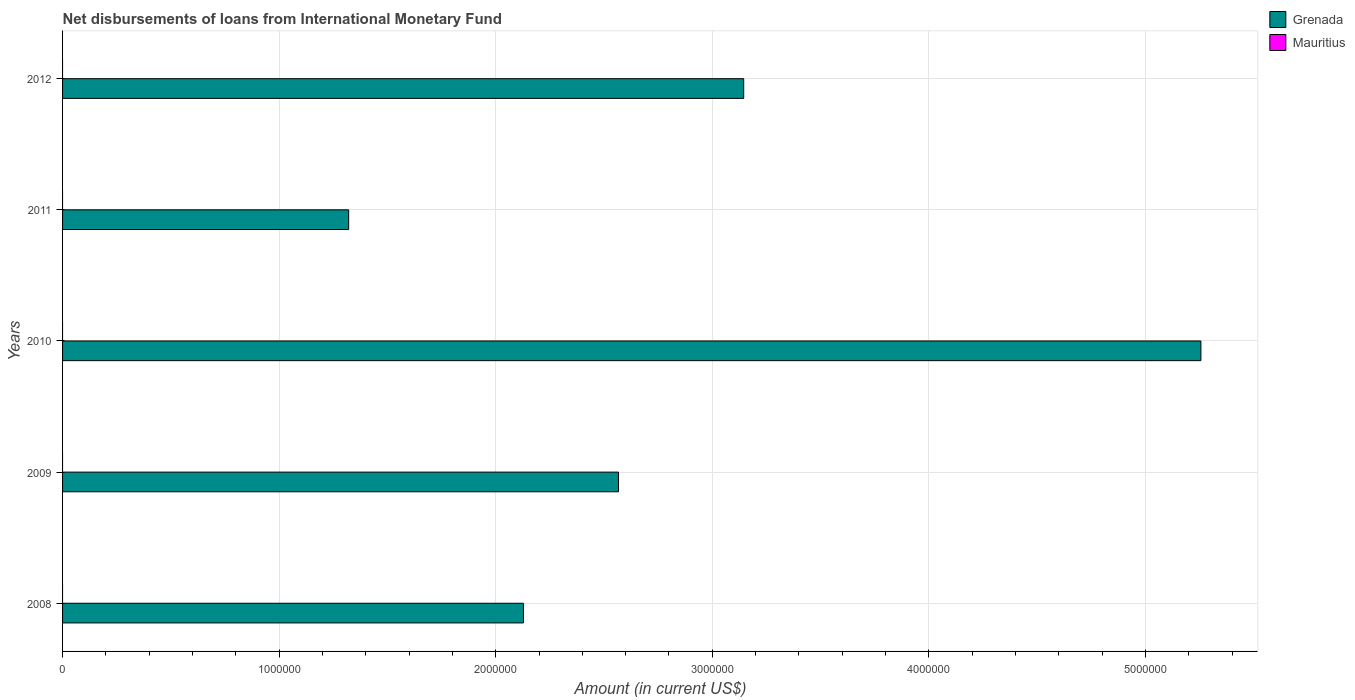How many different coloured bars are there?
Offer a terse response. 1. Are the number of bars on each tick of the Y-axis equal?
Offer a terse response. Yes. How many bars are there on the 5th tick from the top?
Your answer should be very brief. 1. How many bars are there on the 3rd tick from the bottom?
Provide a short and direct response. 1. What is the label of the 1st group of bars from the top?
Keep it short and to the point. 2012. In how many cases, is the number of bars for a given year not equal to the number of legend labels?
Give a very brief answer. 5. What is the amount of loans disbursed in Grenada in 2011?
Give a very brief answer. 1.32e+06. Across all years, what is the maximum amount of loans disbursed in Grenada?
Your answer should be compact. 5.26e+06. Across all years, what is the minimum amount of loans disbursed in Grenada?
Offer a terse response. 1.32e+06. What is the total amount of loans disbursed in Mauritius in the graph?
Make the answer very short. 0. What is the difference between the amount of loans disbursed in Grenada in 2008 and that in 2010?
Your answer should be very brief. -3.13e+06. What is the difference between the amount of loans disbursed in Mauritius in 2010 and the amount of loans disbursed in Grenada in 2012?
Offer a terse response. -3.14e+06. What is the ratio of the amount of loans disbursed in Grenada in 2008 to that in 2010?
Your response must be concise. 0.4. What is the difference between the highest and the second highest amount of loans disbursed in Grenada?
Keep it short and to the point. 2.11e+06. What is the difference between the highest and the lowest amount of loans disbursed in Grenada?
Provide a succinct answer. 3.94e+06. In how many years, is the amount of loans disbursed in Grenada greater than the average amount of loans disbursed in Grenada taken over all years?
Give a very brief answer. 2. Is the sum of the amount of loans disbursed in Grenada in 2009 and 2011 greater than the maximum amount of loans disbursed in Mauritius across all years?
Provide a short and direct response. Yes. How many years are there in the graph?
Give a very brief answer. 5. What is the difference between two consecutive major ticks on the X-axis?
Provide a short and direct response. 1.00e+06. Does the graph contain any zero values?
Your answer should be very brief. Yes. Does the graph contain grids?
Offer a very short reply. Yes. Where does the legend appear in the graph?
Give a very brief answer. Top right. What is the title of the graph?
Make the answer very short. Net disbursements of loans from International Monetary Fund. What is the Amount (in current US$) of Grenada in 2008?
Make the answer very short. 2.13e+06. What is the Amount (in current US$) in Grenada in 2009?
Provide a short and direct response. 2.57e+06. What is the Amount (in current US$) in Grenada in 2010?
Offer a terse response. 5.26e+06. What is the Amount (in current US$) in Mauritius in 2010?
Make the answer very short. 0. What is the Amount (in current US$) in Grenada in 2011?
Offer a terse response. 1.32e+06. What is the Amount (in current US$) in Mauritius in 2011?
Your response must be concise. 0. What is the Amount (in current US$) of Grenada in 2012?
Provide a succinct answer. 3.14e+06. Across all years, what is the maximum Amount (in current US$) of Grenada?
Keep it short and to the point. 5.26e+06. Across all years, what is the minimum Amount (in current US$) in Grenada?
Offer a terse response. 1.32e+06. What is the total Amount (in current US$) in Grenada in the graph?
Ensure brevity in your answer.  1.44e+07. What is the difference between the Amount (in current US$) of Grenada in 2008 and that in 2009?
Keep it short and to the point. -4.39e+05. What is the difference between the Amount (in current US$) of Grenada in 2008 and that in 2010?
Ensure brevity in your answer.  -3.13e+06. What is the difference between the Amount (in current US$) in Grenada in 2008 and that in 2011?
Keep it short and to the point. 8.07e+05. What is the difference between the Amount (in current US$) of Grenada in 2008 and that in 2012?
Keep it short and to the point. -1.02e+06. What is the difference between the Amount (in current US$) of Grenada in 2009 and that in 2010?
Offer a terse response. -2.69e+06. What is the difference between the Amount (in current US$) in Grenada in 2009 and that in 2011?
Your response must be concise. 1.25e+06. What is the difference between the Amount (in current US$) in Grenada in 2009 and that in 2012?
Your answer should be very brief. -5.78e+05. What is the difference between the Amount (in current US$) in Grenada in 2010 and that in 2011?
Offer a terse response. 3.94e+06. What is the difference between the Amount (in current US$) of Grenada in 2010 and that in 2012?
Provide a succinct answer. 2.11e+06. What is the difference between the Amount (in current US$) in Grenada in 2011 and that in 2012?
Your answer should be very brief. -1.82e+06. What is the average Amount (in current US$) in Grenada per year?
Give a very brief answer. 2.88e+06. What is the average Amount (in current US$) in Mauritius per year?
Keep it short and to the point. 0. What is the ratio of the Amount (in current US$) in Grenada in 2008 to that in 2009?
Provide a succinct answer. 0.83. What is the ratio of the Amount (in current US$) in Grenada in 2008 to that in 2010?
Provide a succinct answer. 0.4. What is the ratio of the Amount (in current US$) of Grenada in 2008 to that in 2011?
Your answer should be very brief. 1.61. What is the ratio of the Amount (in current US$) of Grenada in 2008 to that in 2012?
Your response must be concise. 0.68. What is the ratio of the Amount (in current US$) in Grenada in 2009 to that in 2010?
Offer a terse response. 0.49. What is the ratio of the Amount (in current US$) in Grenada in 2009 to that in 2011?
Your answer should be very brief. 1.94. What is the ratio of the Amount (in current US$) of Grenada in 2009 to that in 2012?
Offer a very short reply. 0.82. What is the ratio of the Amount (in current US$) of Grenada in 2010 to that in 2011?
Your response must be concise. 3.98. What is the ratio of the Amount (in current US$) of Grenada in 2010 to that in 2012?
Provide a succinct answer. 1.67. What is the ratio of the Amount (in current US$) of Grenada in 2011 to that in 2012?
Your response must be concise. 0.42. What is the difference between the highest and the second highest Amount (in current US$) of Grenada?
Keep it short and to the point. 2.11e+06. What is the difference between the highest and the lowest Amount (in current US$) of Grenada?
Make the answer very short. 3.94e+06. 